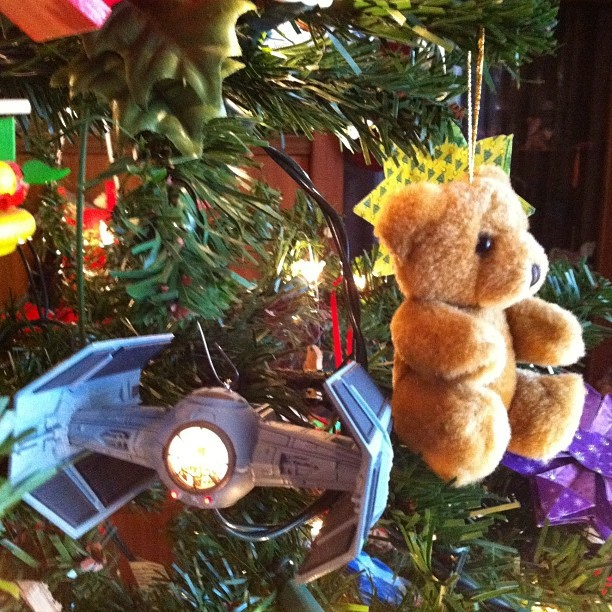Describe the objects in this image and their specific colors. I can see a teddy bear in red, brown, ivory, and tan tones in this image. 